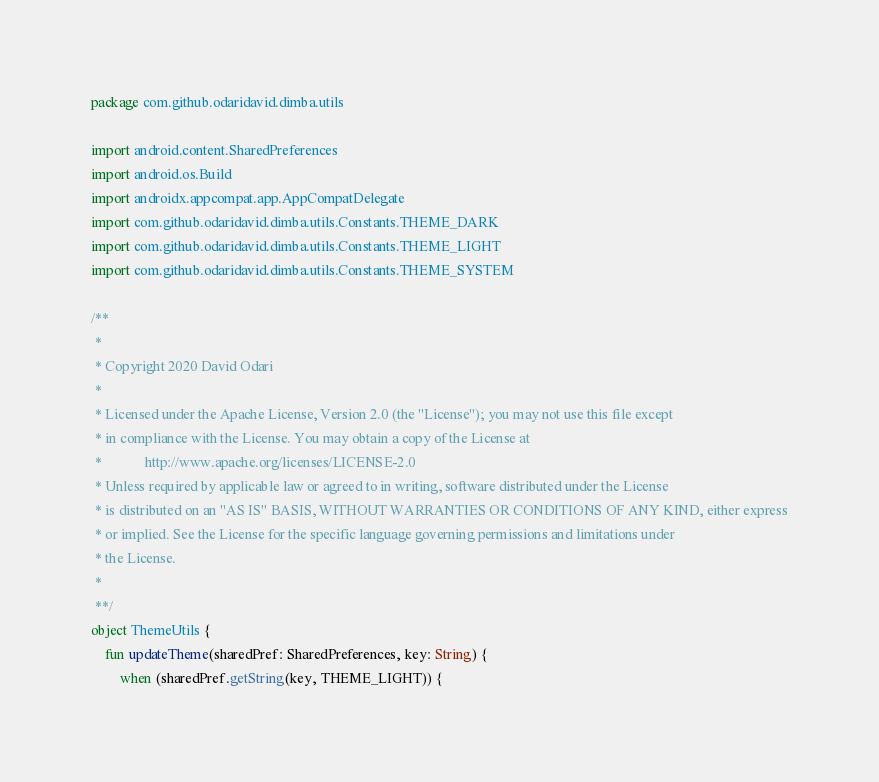<code> <loc_0><loc_0><loc_500><loc_500><_Kotlin_>package com.github.odaridavid.dimba.utils

import android.content.SharedPreferences
import android.os.Build
import androidx.appcompat.app.AppCompatDelegate
import com.github.odaridavid.dimba.utils.Constants.THEME_DARK
import com.github.odaridavid.dimba.utils.Constants.THEME_LIGHT
import com.github.odaridavid.dimba.utils.Constants.THEME_SYSTEM

/**
 *
 * Copyright 2020 David Odari
 *
 * Licensed under the Apache License, Version 2.0 (the "License"); you may not use this file except
 * in compliance with the License. You may obtain a copy of the License at
 *            http://www.apache.org/licenses/LICENSE-2.0
 * Unless required by applicable law or agreed to in writing, software distributed under the License
 * is distributed on an "AS IS" BASIS, WITHOUT WARRANTIES OR CONDITIONS OF ANY KIND, either express
 * or implied. See the License for the specific language governing permissions and limitations under
 * the License.
 *
 **/
object ThemeUtils {
    fun updateTheme(sharedPref: SharedPreferences, key: String) {
        when (sharedPref.getString(key, THEME_LIGHT)) {</code> 